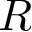Convert formula to latex. <formula><loc_0><loc_0><loc_500><loc_500>R</formula> 